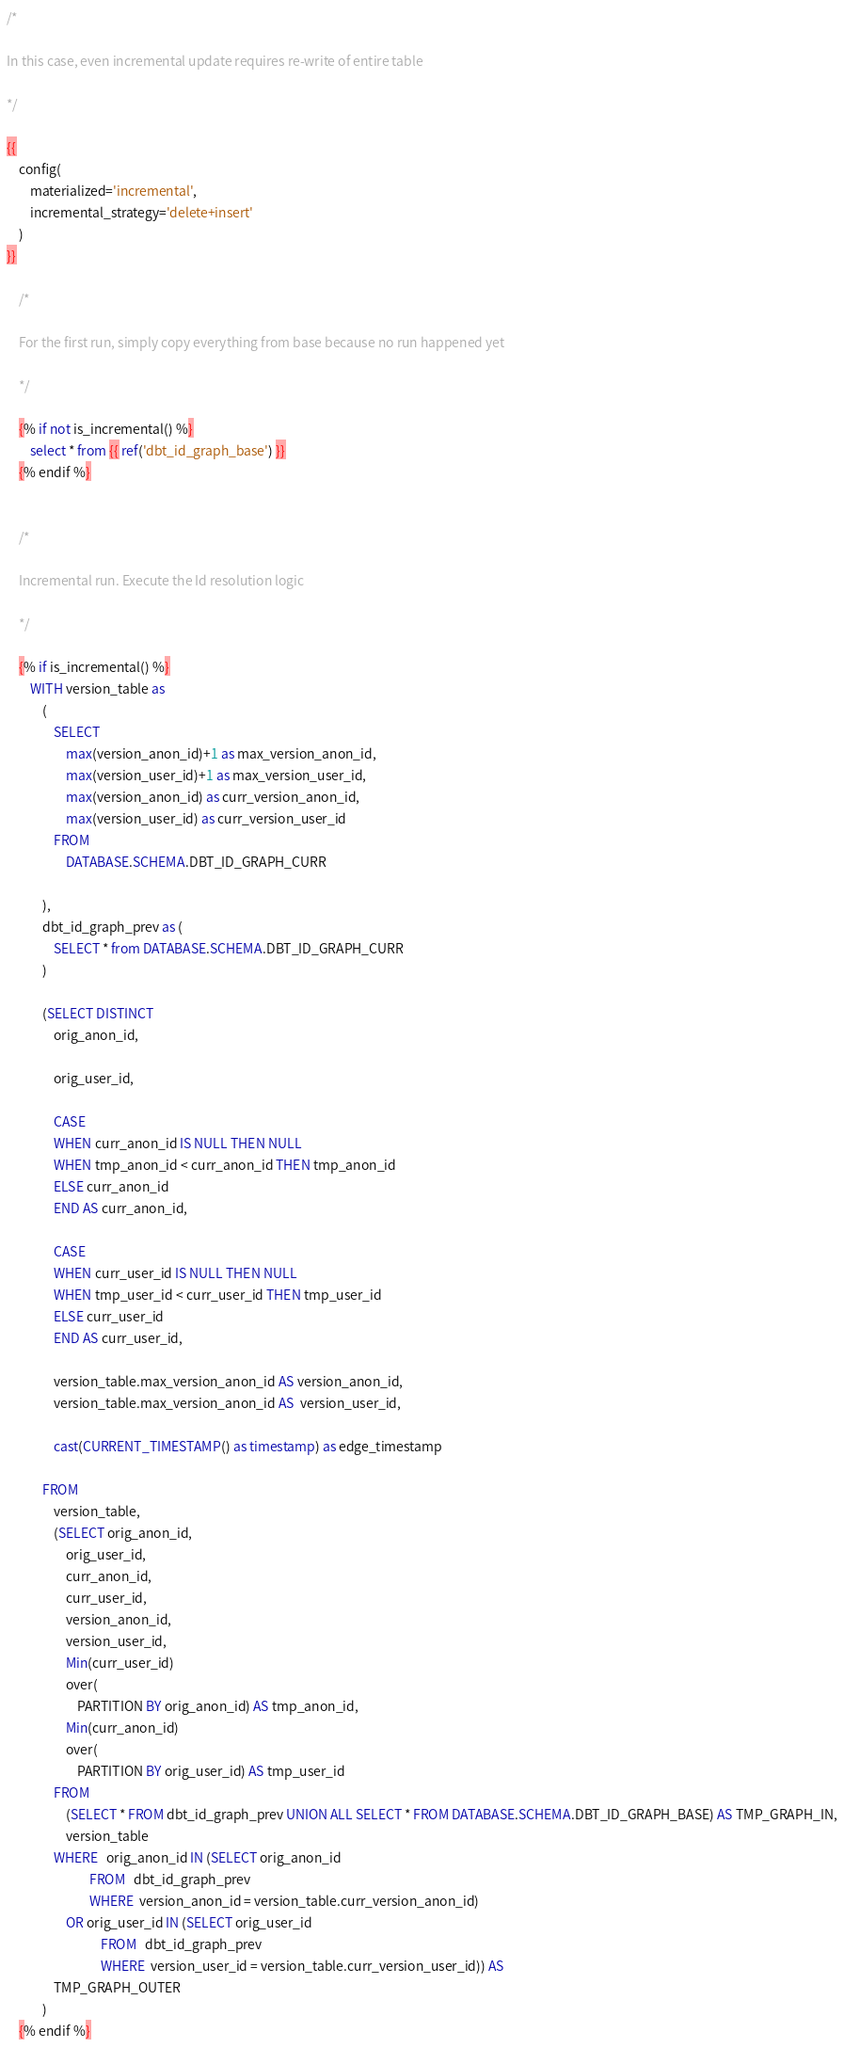Convert code to text. <code><loc_0><loc_0><loc_500><loc_500><_SQL_>/*

In this case, even incremental update requires re-write of entire table

*/

{{
    config(
        materialized='incremental',
        incremental_strategy='delete+insert'
    )
}}

    /*

    For the first run, simply copy everything from base because no run happened yet

    */

    {% if not is_incremental() %}
        select * from {{ ref('dbt_id_graph_base') }}
    {% endif %}


    /*

    Incremental run. Execute the Id resolution logic

    */
    
    {% if is_incremental() %}
        WITH version_table as 
            (
                SELECT 
                    max(version_anon_id)+1 as max_version_anon_id,
                    max(version_user_id)+1 as max_version_user_id,
                    max(version_anon_id) as curr_version_anon_id,
                    max(version_user_id) as curr_version_user_id
                FROM 
                    DATABASE.SCHEMA.DBT_ID_GRAPH_CURR

            ),
            dbt_id_graph_prev as (
                SELECT * from DATABASE.SCHEMA.DBT_ID_GRAPH_CURR
            )

            (SELECT DISTINCT
                orig_anon_id,

                orig_user_id,

                CASE
                WHEN curr_anon_id IS NULL THEN NULL
                WHEN tmp_anon_id < curr_anon_id THEN tmp_anon_id
                ELSE curr_anon_id
                END AS curr_anon_id,

                CASE
                WHEN curr_user_id IS NULL THEN NULL
                WHEN tmp_user_id < curr_user_id THEN tmp_user_id
                ELSE curr_user_id
                END AS curr_user_id,

                version_table.max_version_anon_id AS version_anon_id,
                version_table.max_version_anon_id AS  version_user_id,
                
                cast(CURRENT_TIMESTAMP() as timestamp) as edge_timestamp

            FROM   
                version_table,
                (SELECT orig_anon_id,
                    orig_user_id,
                    curr_anon_id,
                    curr_user_id,
                    version_anon_id,
                    version_user_id,
                    Min(curr_user_id)
                    over(
                        PARTITION BY orig_anon_id) AS tmp_anon_id,
                    Min(curr_anon_id)
                    over(
                        PARTITION BY orig_user_id) AS tmp_user_id
                FROM   
                    (SELECT * FROM dbt_id_graph_prev UNION ALL SELECT * FROM DATABASE.SCHEMA.DBT_ID_GRAPH_BASE) AS TMP_GRAPH_IN,
                    version_table
                WHERE   orig_anon_id IN (SELECT orig_anon_id
                            FROM   dbt_id_graph_prev
                            WHERE  version_anon_id = version_table.curr_version_anon_id)
                    OR orig_user_id IN (SELECT orig_user_id
                                FROM   dbt_id_graph_prev
                                WHERE  version_user_id = version_table.curr_version_user_id)) AS
                TMP_GRAPH_OUTER
            )
    {% endif %}</code> 